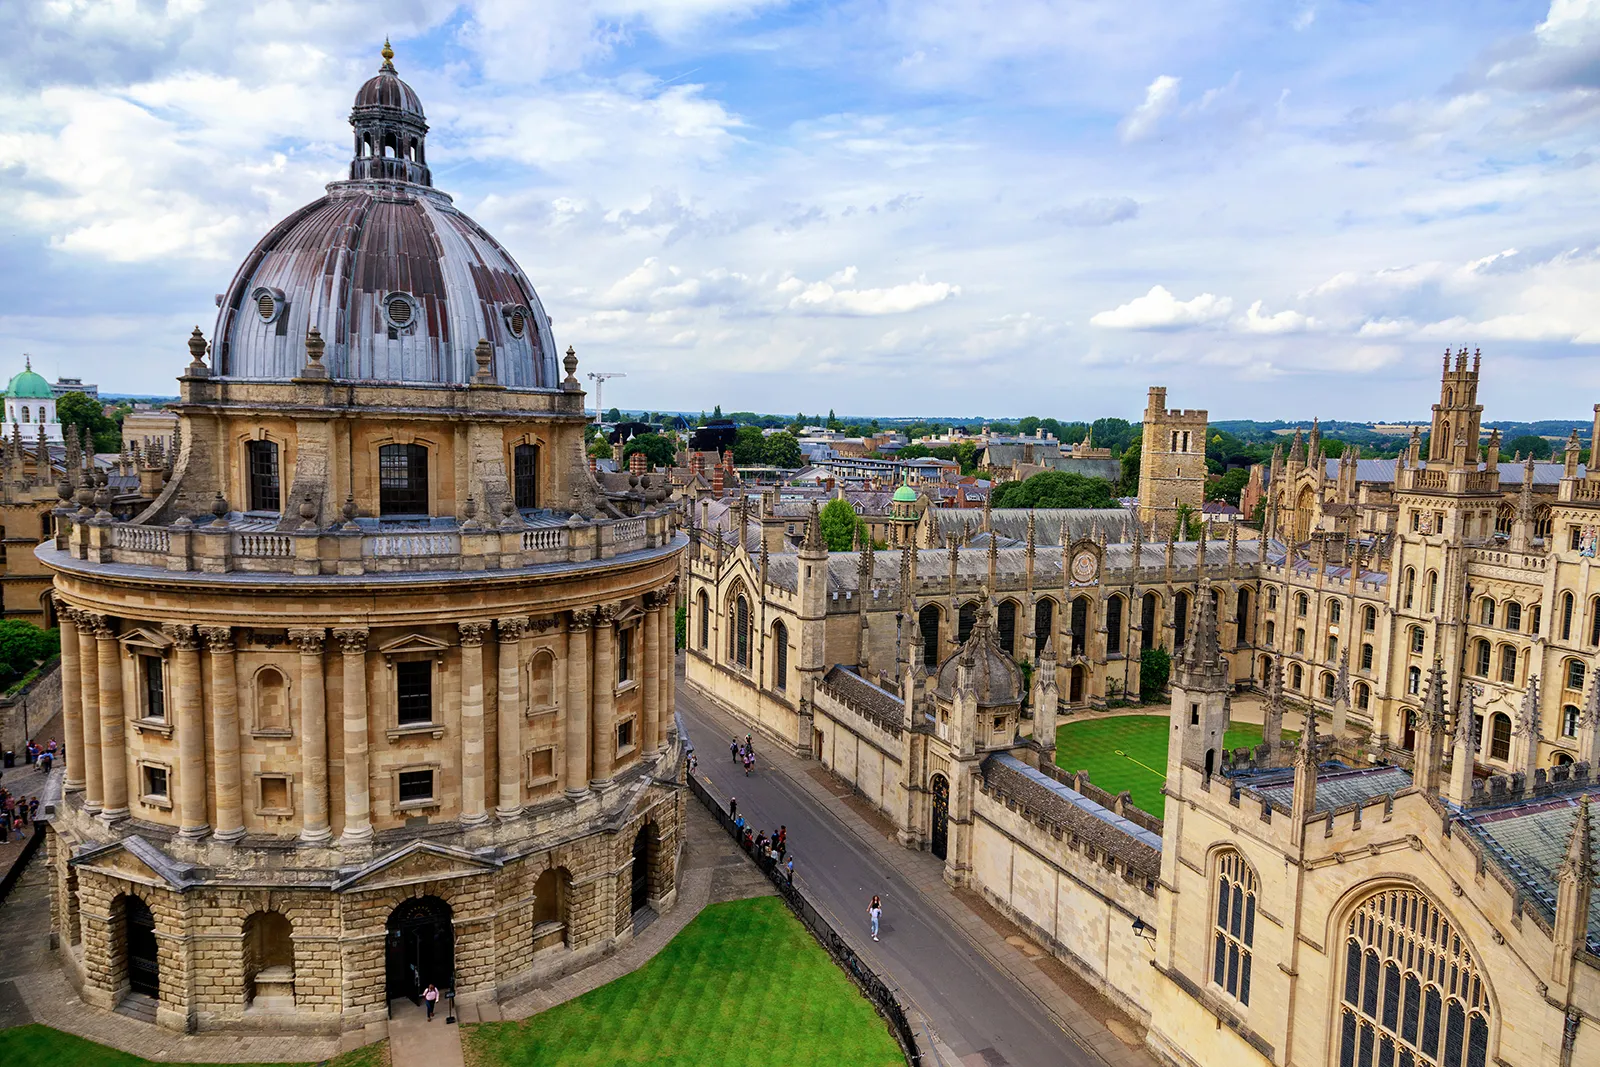Imagine an elaborate historical reenactment event held at this location. What might it include? An elaborate historical reenactment event at the Radcliffe Camera could include actors dressed in 18th-century garb, recreating the era when the library was first built. The event might start with a grand opening ceremony, featuring a speech by a figure portraying John Radcliffe, followed by scenes depicting the construction of the building, complete with masons and architects debating the design. There could be scholarly discussions reenacted by actors playing historical academics, reflecting on the scientific discoveries of the time. The day could also include period-appropriate music, dances, and a market showcasing 18th-century crafts and foods. The reenactment would offer a vivid glimpse into the life and times of those who walked the sharegpt4v/same grounds centuries ago. 